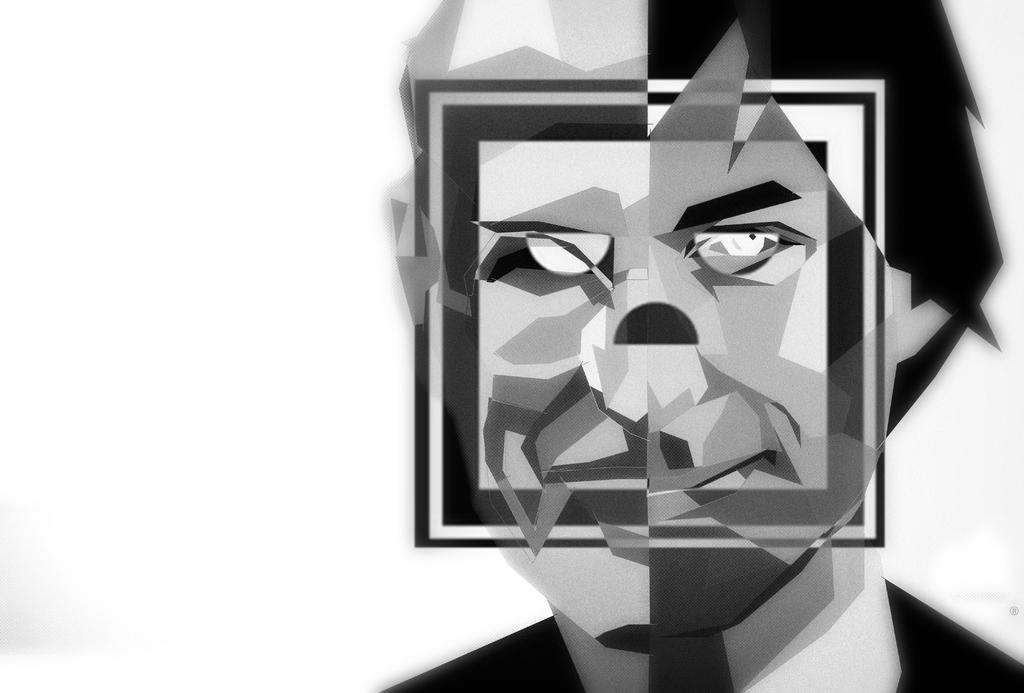What type of image is this? The image is an edited image of a person. What color scheme is used in the image? The image is in black and white color. What type of yarn is being used to create the person's hair in the image? There is no yarn present in the image, as it is a black and white edited image of a person. What scale is used to measure the person's height in the image? There is no scale present in the image, and the person's height is not being measured. 